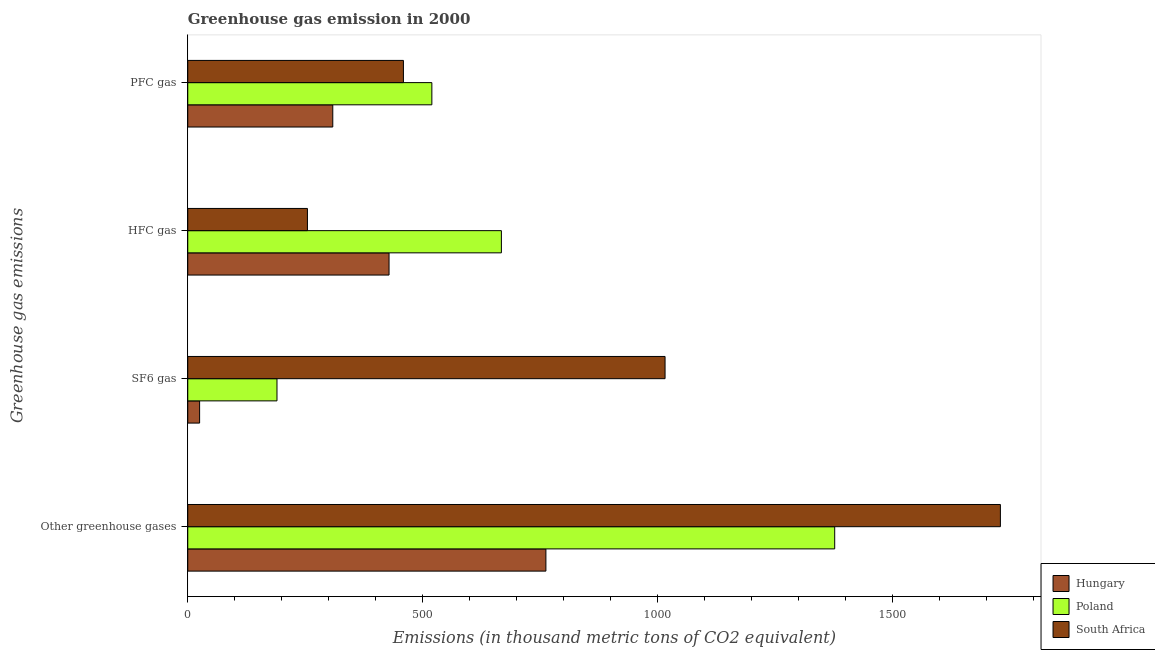Are the number of bars per tick equal to the number of legend labels?
Ensure brevity in your answer.  Yes. What is the label of the 4th group of bars from the top?
Your answer should be compact. Other greenhouse gases. What is the emission of hfc gas in South Africa?
Your response must be concise. 254.6. Across all countries, what is the maximum emission of sf6 gas?
Your answer should be compact. 1015.4. Across all countries, what is the minimum emission of greenhouse gases?
Make the answer very short. 761.9. In which country was the emission of pfc gas minimum?
Make the answer very short. Hungary. What is the total emission of greenhouse gases in the graph?
Give a very brief answer. 3867. What is the difference between the emission of hfc gas in Hungary and that in Poland?
Make the answer very short. -239. What is the difference between the emission of greenhouse gases in South Africa and the emission of sf6 gas in Hungary?
Make the answer very short. 1703.6. What is the average emission of pfc gas per country?
Provide a short and direct response. 428.87. What is the difference between the emission of sf6 gas and emission of pfc gas in Hungary?
Ensure brevity in your answer.  -283.3. What is the ratio of the emission of greenhouse gases in South Africa to that in Poland?
Your answer should be very brief. 1.26. Is the difference between the emission of pfc gas in Poland and South Africa greater than the difference between the emission of greenhouse gases in Poland and South Africa?
Provide a succinct answer. Yes. What is the difference between the highest and the second highest emission of hfc gas?
Your response must be concise. 239. What is the difference between the highest and the lowest emission of greenhouse gases?
Offer a very short reply. 966.9. In how many countries, is the emission of hfc gas greater than the average emission of hfc gas taken over all countries?
Give a very brief answer. 1. What does the 3rd bar from the top in Other greenhouse gases represents?
Keep it short and to the point. Hungary. How many bars are there?
Make the answer very short. 12. Are all the bars in the graph horizontal?
Your answer should be very brief. Yes. How many countries are there in the graph?
Offer a terse response. 3. How many legend labels are there?
Your answer should be compact. 3. What is the title of the graph?
Make the answer very short. Greenhouse gas emission in 2000. What is the label or title of the X-axis?
Offer a terse response. Emissions (in thousand metric tons of CO2 equivalent). What is the label or title of the Y-axis?
Your answer should be very brief. Greenhouse gas emissions. What is the Emissions (in thousand metric tons of CO2 equivalent) of Hungary in Other greenhouse gases?
Offer a terse response. 761.9. What is the Emissions (in thousand metric tons of CO2 equivalent) of Poland in Other greenhouse gases?
Your response must be concise. 1376.3. What is the Emissions (in thousand metric tons of CO2 equivalent) of South Africa in Other greenhouse gases?
Ensure brevity in your answer.  1728.8. What is the Emissions (in thousand metric tons of CO2 equivalent) of Hungary in SF6 gas?
Your answer should be compact. 25.2. What is the Emissions (in thousand metric tons of CO2 equivalent) of Poland in SF6 gas?
Give a very brief answer. 189.8. What is the Emissions (in thousand metric tons of CO2 equivalent) in South Africa in SF6 gas?
Provide a short and direct response. 1015.4. What is the Emissions (in thousand metric tons of CO2 equivalent) of Hungary in HFC gas?
Keep it short and to the point. 428.2. What is the Emissions (in thousand metric tons of CO2 equivalent) in Poland in HFC gas?
Provide a succinct answer. 667.2. What is the Emissions (in thousand metric tons of CO2 equivalent) in South Africa in HFC gas?
Ensure brevity in your answer.  254.6. What is the Emissions (in thousand metric tons of CO2 equivalent) in Hungary in PFC gas?
Offer a terse response. 308.5. What is the Emissions (in thousand metric tons of CO2 equivalent) in Poland in PFC gas?
Your response must be concise. 519.3. What is the Emissions (in thousand metric tons of CO2 equivalent) of South Africa in PFC gas?
Ensure brevity in your answer.  458.8. Across all Greenhouse gas emissions, what is the maximum Emissions (in thousand metric tons of CO2 equivalent) in Hungary?
Provide a succinct answer. 761.9. Across all Greenhouse gas emissions, what is the maximum Emissions (in thousand metric tons of CO2 equivalent) in Poland?
Keep it short and to the point. 1376.3. Across all Greenhouse gas emissions, what is the maximum Emissions (in thousand metric tons of CO2 equivalent) of South Africa?
Make the answer very short. 1728.8. Across all Greenhouse gas emissions, what is the minimum Emissions (in thousand metric tons of CO2 equivalent) in Hungary?
Keep it short and to the point. 25.2. Across all Greenhouse gas emissions, what is the minimum Emissions (in thousand metric tons of CO2 equivalent) of Poland?
Your response must be concise. 189.8. Across all Greenhouse gas emissions, what is the minimum Emissions (in thousand metric tons of CO2 equivalent) in South Africa?
Ensure brevity in your answer.  254.6. What is the total Emissions (in thousand metric tons of CO2 equivalent) of Hungary in the graph?
Provide a short and direct response. 1523.8. What is the total Emissions (in thousand metric tons of CO2 equivalent) in Poland in the graph?
Provide a succinct answer. 2752.6. What is the total Emissions (in thousand metric tons of CO2 equivalent) in South Africa in the graph?
Make the answer very short. 3457.6. What is the difference between the Emissions (in thousand metric tons of CO2 equivalent) of Hungary in Other greenhouse gases and that in SF6 gas?
Offer a very short reply. 736.7. What is the difference between the Emissions (in thousand metric tons of CO2 equivalent) in Poland in Other greenhouse gases and that in SF6 gas?
Ensure brevity in your answer.  1186.5. What is the difference between the Emissions (in thousand metric tons of CO2 equivalent) in South Africa in Other greenhouse gases and that in SF6 gas?
Offer a very short reply. 713.4. What is the difference between the Emissions (in thousand metric tons of CO2 equivalent) of Hungary in Other greenhouse gases and that in HFC gas?
Give a very brief answer. 333.7. What is the difference between the Emissions (in thousand metric tons of CO2 equivalent) of Poland in Other greenhouse gases and that in HFC gas?
Offer a terse response. 709.1. What is the difference between the Emissions (in thousand metric tons of CO2 equivalent) of South Africa in Other greenhouse gases and that in HFC gas?
Make the answer very short. 1474.2. What is the difference between the Emissions (in thousand metric tons of CO2 equivalent) in Hungary in Other greenhouse gases and that in PFC gas?
Offer a terse response. 453.4. What is the difference between the Emissions (in thousand metric tons of CO2 equivalent) in Poland in Other greenhouse gases and that in PFC gas?
Offer a very short reply. 857. What is the difference between the Emissions (in thousand metric tons of CO2 equivalent) of South Africa in Other greenhouse gases and that in PFC gas?
Keep it short and to the point. 1270. What is the difference between the Emissions (in thousand metric tons of CO2 equivalent) of Hungary in SF6 gas and that in HFC gas?
Keep it short and to the point. -403. What is the difference between the Emissions (in thousand metric tons of CO2 equivalent) of Poland in SF6 gas and that in HFC gas?
Offer a very short reply. -477.4. What is the difference between the Emissions (in thousand metric tons of CO2 equivalent) of South Africa in SF6 gas and that in HFC gas?
Provide a short and direct response. 760.8. What is the difference between the Emissions (in thousand metric tons of CO2 equivalent) of Hungary in SF6 gas and that in PFC gas?
Your answer should be compact. -283.3. What is the difference between the Emissions (in thousand metric tons of CO2 equivalent) in Poland in SF6 gas and that in PFC gas?
Provide a succinct answer. -329.5. What is the difference between the Emissions (in thousand metric tons of CO2 equivalent) in South Africa in SF6 gas and that in PFC gas?
Make the answer very short. 556.6. What is the difference between the Emissions (in thousand metric tons of CO2 equivalent) in Hungary in HFC gas and that in PFC gas?
Keep it short and to the point. 119.7. What is the difference between the Emissions (in thousand metric tons of CO2 equivalent) in Poland in HFC gas and that in PFC gas?
Make the answer very short. 147.9. What is the difference between the Emissions (in thousand metric tons of CO2 equivalent) in South Africa in HFC gas and that in PFC gas?
Make the answer very short. -204.2. What is the difference between the Emissions (in thousand metric tons of CO2 equivalent) in Hungary in Other greenhouse gases and the Emissions (in thousand metric tons of CO2 equivalent) in Poland in SF6 gas?
Provide a succinct answer. 572.1. What is the difference between the Emissions (in thousand metric tons of CO2 equivalent) of Hungary in Other greenhouse gases and the Emissions (in thousand metric tons of CO2 equivalent) of South Africa in SF6 gas?
Keep it short and to the point. -253.5. What is the difference between the Emissions (in thousand metric tons of CO2 equivalent) of Poland in Other greenhouse gases and the Emissions (in thousand metric tons of CO2 equivalent) of South Africa in SF6 gas?
Offer a very short reply. 360.9. What is the difference between the Emissions (in thousand metric tons of CO2 equivalent) in Hungary in Other greenhouse gases and the Emissions (in thousand metric tons of CO2 equivalent) in Poland in HFC gas?
Your answer should be compact. 94.7. What is the difference between the Emissions (in thousand metric tons of CO2 equivalent) in Hungary in Other greenhouse gases and the Emissions (in thousand metric tons of CO2 equivalent) in South Africa in HFC gas?
Make the answer very short. 507.3. What is the difference between the Emissions (in thousand metric tons of CO2 equivalent) in Poland in Other greenhouse gases and the Emissions (in thousand metric tons of CO2 equivalent) in South Africa in HFC gas?
Ensure brevity in your answer.  1121.7. What is the difference between the Emissions (in thousand metric tons of CO2 equivalent) of Hungary in Other greenhouse gases and the Emissions (in thousand metric tons of CO2 equivalent) of Poland in PFC gas?
Ensure brevity in your answer.  242.6. What is the difference between the Emissions (in thousand metric tons of CO2 equivalent) in Hungary in Other greenhouse gases and the Emissions (in thousand metric tons of CO2 equivalent) in South Africa in PFC gas?
Make the answer very short. 303.1. What is the difference between the Emissions (in thousand metric tons of CO2 equivalent) in Poland in Other greenhouse gases and the Emissions (in thousand metric tons of CO2 equivalent) in South Africa in PFC gas?
Offer a very short reply. 917.5. What is the difference between the Emissions (in thousand metric tons of CO2 equivalent) of Hungary in SF6 gas and the Emissions (in thousand metric tons of CO2 equivalent) of Poland in HFC gas?
Offer a very short reply. -642. What is the difference between the Emissions (in thousand metric tons of CO2 equivalent) of Hungary in SF6 gas and the Emissions (in thousand metric tons of CO2 equivalent) of South Africa in HFC gas?
Ensure brevity in your answer.  -229.4. What is the difference between the Emissions (in thousand metric tons of CO2 equivalent) of Poland in SF6 gas and the Emissions (in thousand metric tons of CO2 equivalent) of South Africa in HFC gas?
Your response must be concise. -64.8. What is the difference between the Emissions (in thousand metric tons of CO2 equivalent) of Hungary in SF6 gas and the Emissions (in thousand metric tons of CO2 equivalent) of Poland in PFC gas?
Your answer should be compact. -494.1. What is the difference between the Emissions (in thousand metric tons of CO2 equivalent) in Hungary in SF6 gas and the Emissions (in thousand metric tons of CO2 equivalent) in South Africa in PFC gas?
Provide a short and direct response. -433.6. What is the difference between the Emissions (in thousand metric tons of CO2 equivalent) in Poland in SF6 gas and the Emissions (in thousand metric tons of CO2 equivalent) in South Africa in PFC gas?
Offer a very short reply. -269. What is the difference between the Emissions (in thousand metric tons of CO2 equivalent) in Hungary in HFC gas and the Emissions (in thousand metric tons of CO2 equivalent) in Poland in PFC gas?
Keep it short and to the point. -91.1. What is the difference between the Emissions (in thousand metric tons of CO2 equivalent) in Hungary in HFC gas and the Emissions (in thousand metric tons of CO2 equivalent) in South Africa in PFC gas?
Offer a terse response. -30.6. What is the difference between the Emissions (in thousand metric tons of CO2 equivalent) of Poland in HFC gas and the Emissions (in thousand metric tons of CO2 equivalent) of South Africa in PFC gas?
Keep it short and to the point. 208.4. What is the average Emissions (in thousand metric tons of CO2 equivalent) in Hungary per Greenhouse gas emissions?
Give a very brief answer. 380.95. What is the average Emissions (in thousand metric tons of CO2 equivalent) of Poland per Greenhouse gas emissions?
Your answer should be compact. 688.15. What is the average Emissions (in thousand metric tons of CO2 equivalent) of South Africa per Greenhouse gas emissions?
Make the answer very short. 864.4. What is the difference between the Emissions (in thousand metric tons of CO2 equivalent) in Hungary and Emissions (in thousand metric tons of CO2 equivalent) in Poland in Other greenhouse gases?
Provide a short and direct response. -614.4. What is the difference between the Emissions (in thousand metric tons of CO2 equivalent) in Hungary and Emissions (in thousand metric tons of CO2 equivalent) in South Africa in Other greenhouse gases?
Your answer should be compact. -966.9. What is the difference between the Emissions (in thousand metric tons of CO2 equivalent) in Poland and Emissions (in thousand metric tons of CO2 equivalent) in South Africa in Other greenhouse gases?
Your response must be concise. -352.5. What is the difference between the Emissions (in thousand metric tons of CO2 equivalent) of Hungary and Emissions (in thousand metric tons of CO2 equivalent) of Poland in SF6 gas?
Keep it short and to the point. -164.6. What is the difference between the Emissions (in thousand metric tons of CO2 equivalent) in Hungary and Emissions (in thousand metric tons of CO2 equivalent) in South Africa in SF6 gas?
Give a very brief answer. -990.2. What is the difference between the Emissions (in thousand metric tons of CO2 equivalent) in Poland and Emissions (in thousand metric tons of CO2 equivalent) in South Africa in SF6 gas?
Offer a terse response. -825.6. What is the difference between the Emissions (in thousand metric tons of CO2 equivalent) of Hungary and Emissions (in thousand metric tons of CO2 equivalent) of Poland in HFC gas?
Provide a short and direct response. -239. What is the difference between the Emissions (in thousand metric tons of CO2 equivalent) in Hungary and Emissions (in thousand metric tons of CO2 equivalent) in South Africa in HFC gas?
Your response must be concise. 173.6. What is the difference between the Emissions (in thousand metric tons of CO2 equivalent) in Poland and Emissions (in thousand metric tons of CO2 equivalent) in South Africa in HFC gas?
Give a very brief answer. 412.6. What is the difference between the Emissions (in thousand metric tons of CO2 equivalent) of Hungary and Emissions (in thousand metric tons of CO2 equivalent) of Poland in PFC gas?
Make the answer very short. -210.8. What is the difference between the Emissions (in thousand metric tons of CO2 equivalent) of Hungary and Emissions (in thousand metric tons of CO2 equivalent) of South Africa in PFC gas?
Keep it short and to the point. -150.3. What is the difference between the Emissions (in thousand metric tons of CO2 equivalent) of Poland and Emissions (in thousand metric tons of CO2 equivalent) of South Africa in PFC gas?
Your response must be concise. 60.5. What is the ratio of the Emissions (in thousand metric tons of CO2 equivalent) in Hungary in Other greenhouse gases to that in SF6 gas?
Your response must be concise. 30.23. What is the ratio of the Emissions (in thousand metric tons of CO2 equivalent) in Poland in Other greenhouse gases to that in SF6 gas?
Ensure brevity in your answer.  7.25. What is the ratio of the Emissions (in thousand metric tons of CO2 equivalent) in South Africa in Other greenhouse gases to that in SF6 gas?
Provide a succinct answer. 1.7. What is the ratio of the Emissions (in thousand metric tons of CO2 equivalent) of Hungary in Other greenhouse gases to that in HFC gas?
Your answer should be compact. 1.78. What is the ratio of the Emissions (in thousand metric tons of CO2 equivalent) in Poland in Other greenhouse gases to that in HFC gas?
Your answer should be compact. 2.06. What is the ratio of the Emissions (in thousand metric tons of CO2 equivalent) of South Africa in Other greenhouse gases to that in HFC gas?
Give a very brief answer. 6.79. What is the ratio of the Emissions (in thousand metric tons of CO2 equivalent) in Hungary in Other greenhouse gases to that in PFC gas?
Give a very brief answer. 2.47. What is the ratio of the Emissions (in thousand metric tons of CO2 equivalent) in Poland in Other greenhouse gases to that in PFC gas?
Provide a succinct answer. 2.65. What is the ratio of the Emissions (in thousand metric tons of CO2 equivalent) of South Africa in Other greenhouse gases to that in PFC gas?
Give a very brief answer. 3.77. What is the ratio of the Emissions (in thousand metric tons of CO2 equivalent) in Hungary in SF6 gas to that in HFC gas?
Offer a terse response. 0.06. What is the ratio of the Emissions (in thousand metric tons of CO2 equivalent) in Poland in SF6 gas to that in HFC gas?
Keep it short and to the point. 0.28. What is the ratio of the Emissions (in thousand metric tons of CO2 equivalent) in South Africa in SF6 gas to that in HFC gas?
Provide a succinct answer. 3.99. What is the ratio of the Emissions (in thousand metric tons of CO2 equivalent) in Hungary in SF6 gas to that in PFC gas?
Your answer should be compact. 0.08. What is the ratio of the Emissions (in thousand metric tons of CO2 equivalent) in Poland in SF6 gas to that in PFC gas?
Provide a short and direct response. 0.37. What is the ratio of the Emissions (in thousand metric tons of CO2 equivalent) of South Africa in SF6 gas to that in PFC gas?
Offer a very short reply. 2.21. What is the ratio of the Emissions (in thousand metric tons of CO2 equivalent) of Hungary in HFC gas to that in PFC gas?
Give a very brief answer. 1.39. What is the ratio of the Emissions (in thousand metric tons of CO2 equivalent) in Poland in HFC gas to that in PFC gas?
Your answer should be very brief. 1.28. What is the ratio of the Emissions (in thousand metric tons of CO2 equivalent) in South Africa in HFC gas to that in PFC gas?
Your answer should be very brief. 0.55. What is the difference between the highest and the second highest Emissions (in thousand metric tons of CO2 equivalent) in Hungary?
Offer a terse response. 333.7. What is the difference between the highest and the second highest Emissions (in thousand metric tons of CO2 equivalent) of Poland?
Give a very brief answer. 709.1. What is the difference between the highest and the second highest Emissions (in thousand metric tons of CO2 equivalent) in South Africa?
Offer a very short reply. 713.4. What is the difference between the highest and the lowest Emissions (in thousand metric tons of CO2 equivalent) in Hungary?
Keep it short and to the point. 736.7. What is the difference between the highest and the lowest Emissions (in thousand metric tons of CO2 equivalent) in Poland?
Make the answer very short. 1186.5. What is the difference between the highest and the lowest Emissions (in thousand metric tons of CO2 equivalent) of South Africa?
Offer a terse response. 1474.2. 